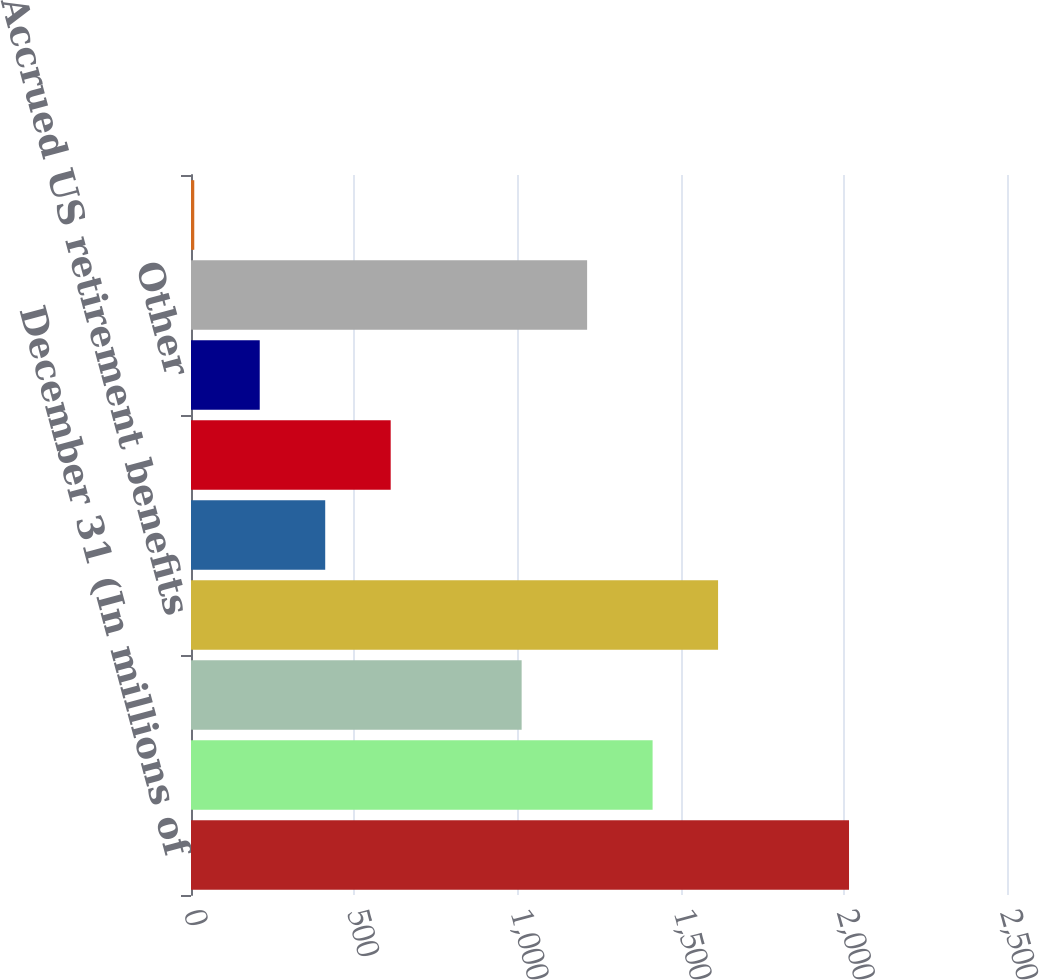Convert chart to OTSL. <chart><loc_0><loc_0><loc_500><loc_500><bar_chart><fcel>December 31 (In millions of<fcel>Accrued expenses not currently<fcel>Differences related to non-US<fcel>Accrued US retirement benefits<fcel>Net operating losses (b)<fcel>Income currently recognized<fcel>Other<fcel>Depreciation and amortization<fcel>Accrued retirement &<nl><fcel>2016<fcel>1414.2<fcel>1013<fcel>1614.8<fcel>411.2<fcel>611.8<fcel>210.6<fcel>1213.6<fcel>10<nl></chart> 